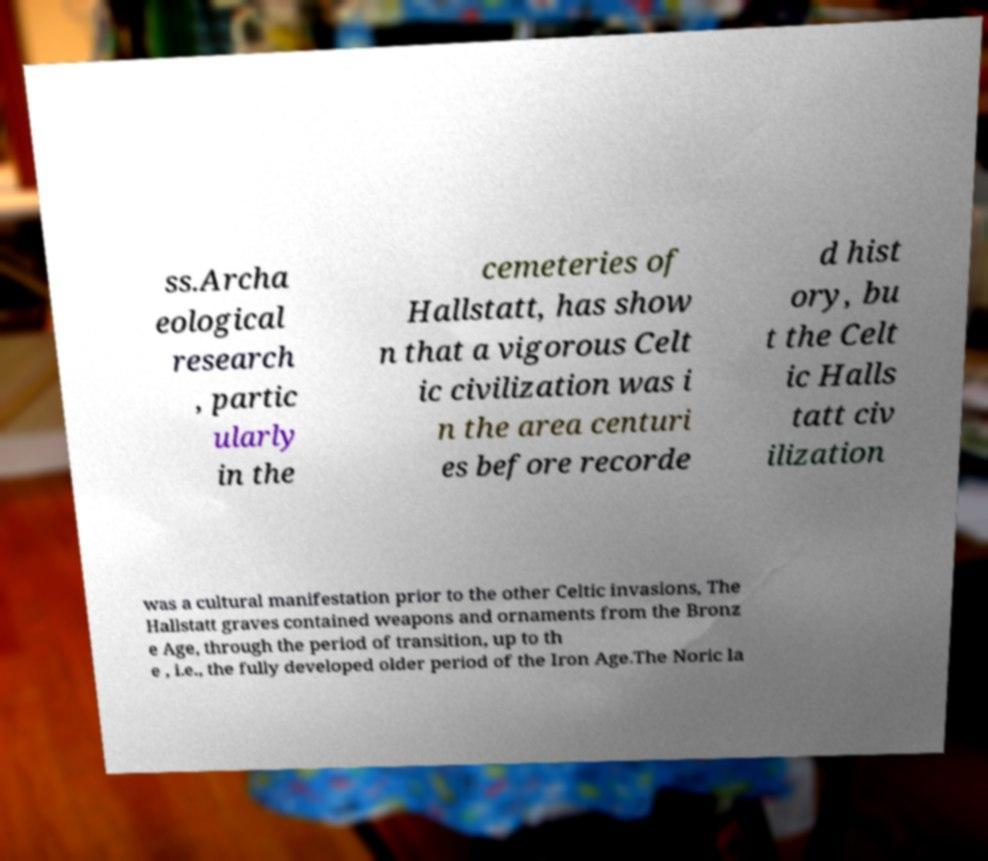Please identify and transcribe the text found in this image. ss.Archa eological research , partic ularly in the cemeteries of Hallstatt, has show n that a vigorous Celt ic civilization was i n the area centuri es before recorde d hist ory, bu t the Celt ic Halls tatt civ ilization was a cultural manifestation prior to the other Celtic invasions, The Hallstatt graves contained weapons and ornaments from the Bronz e Age, through the period of transition, up to th e , i.e., the fully developed older period of the Iron Age.The Noric la 